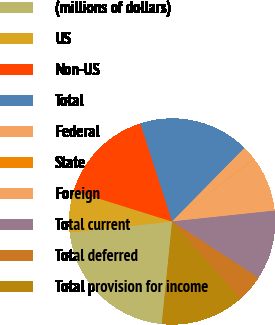Convert chart to OTSL. <chart><loc_0><loc_0><loc_500><loc_500><pie_chart><fcel>(millions of dollars)<fcel>US<fcel>Non-US<fcel>Total<fcel>Federal<fcel>State<fcel>Foreign<fcel>Total current<fcel>Total deferred<fcel>Total provision for income<nl><fcel>21.69%<fcel>6.54%<fcel>15.2%<fcel>17.36%<fcel>2.21%<fcel>0.04%<fcel>8.7%<fcel>10.87%<fcel>4.37%<fcel>13.03%<nl></chart> 